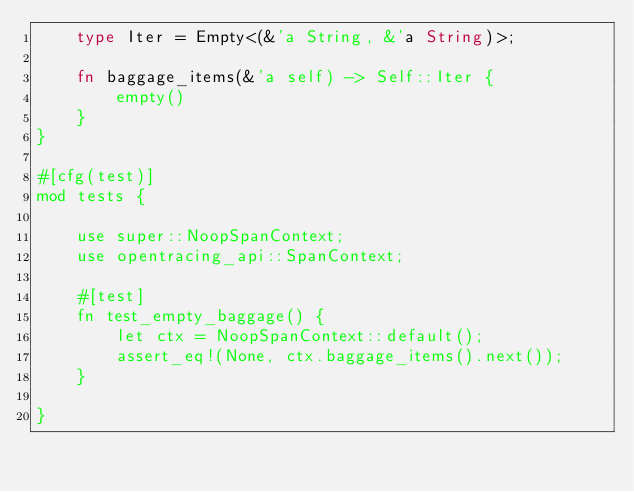<code> <loc_0><loc_0><loc_500><loc_500><_Rust_>    type Iter = Empty<(&'a String, &'a String)>;

    fn baggage_items(&'a self) -> Self::Iter {
        empty()
    }
}

#[cfg(test)]
mod tests {

    use super::NoopSpanContext;
    use opentracing_api::SpanContext;

    #[test]
    fn test_empty_baggage() {
        let ctx = NoopSpanContext::default();
        assert_eq!(None, ctx.baggage_items().next());
    }

}
</code> 